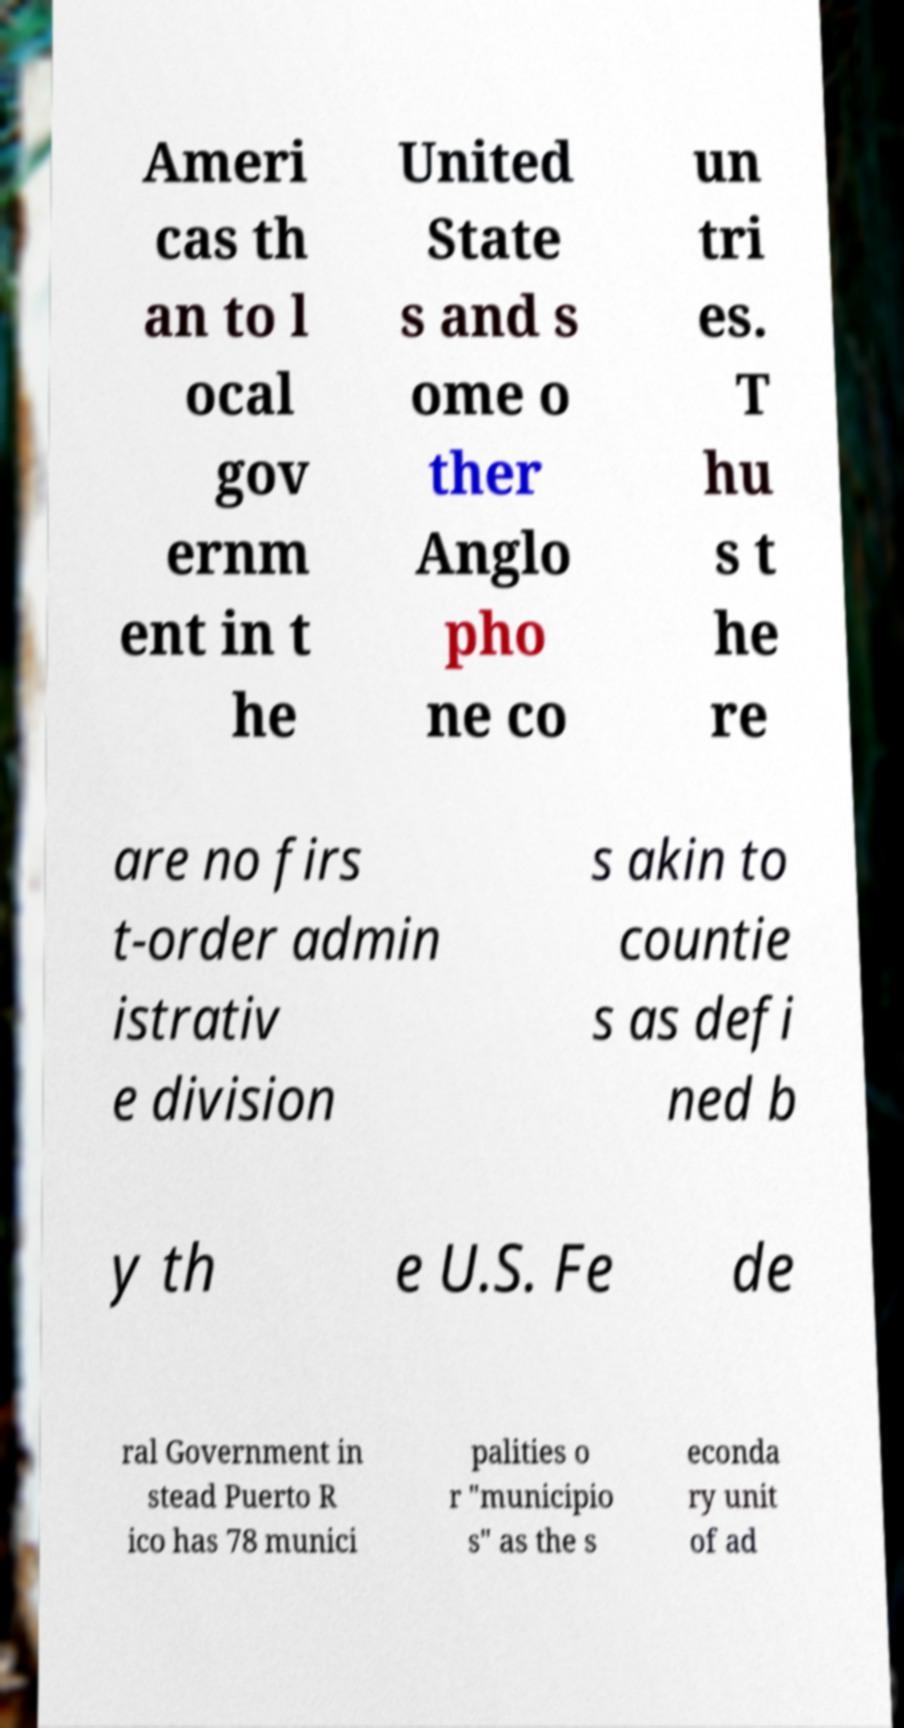Could you extract and type out the text from this image? Ameri cas th an to l ocal gov ernm ent in t he United State s and s ome o ther Anglo pho ne co un tri es. T hu s t he re are no firs t-order admin istrativ e division s akin to countie s as defi ned b y th e U.S. Fe de ral Government in stead Puerto R ico has 78 munici palities o r "municipio s" as the s econda ry unit of ad 